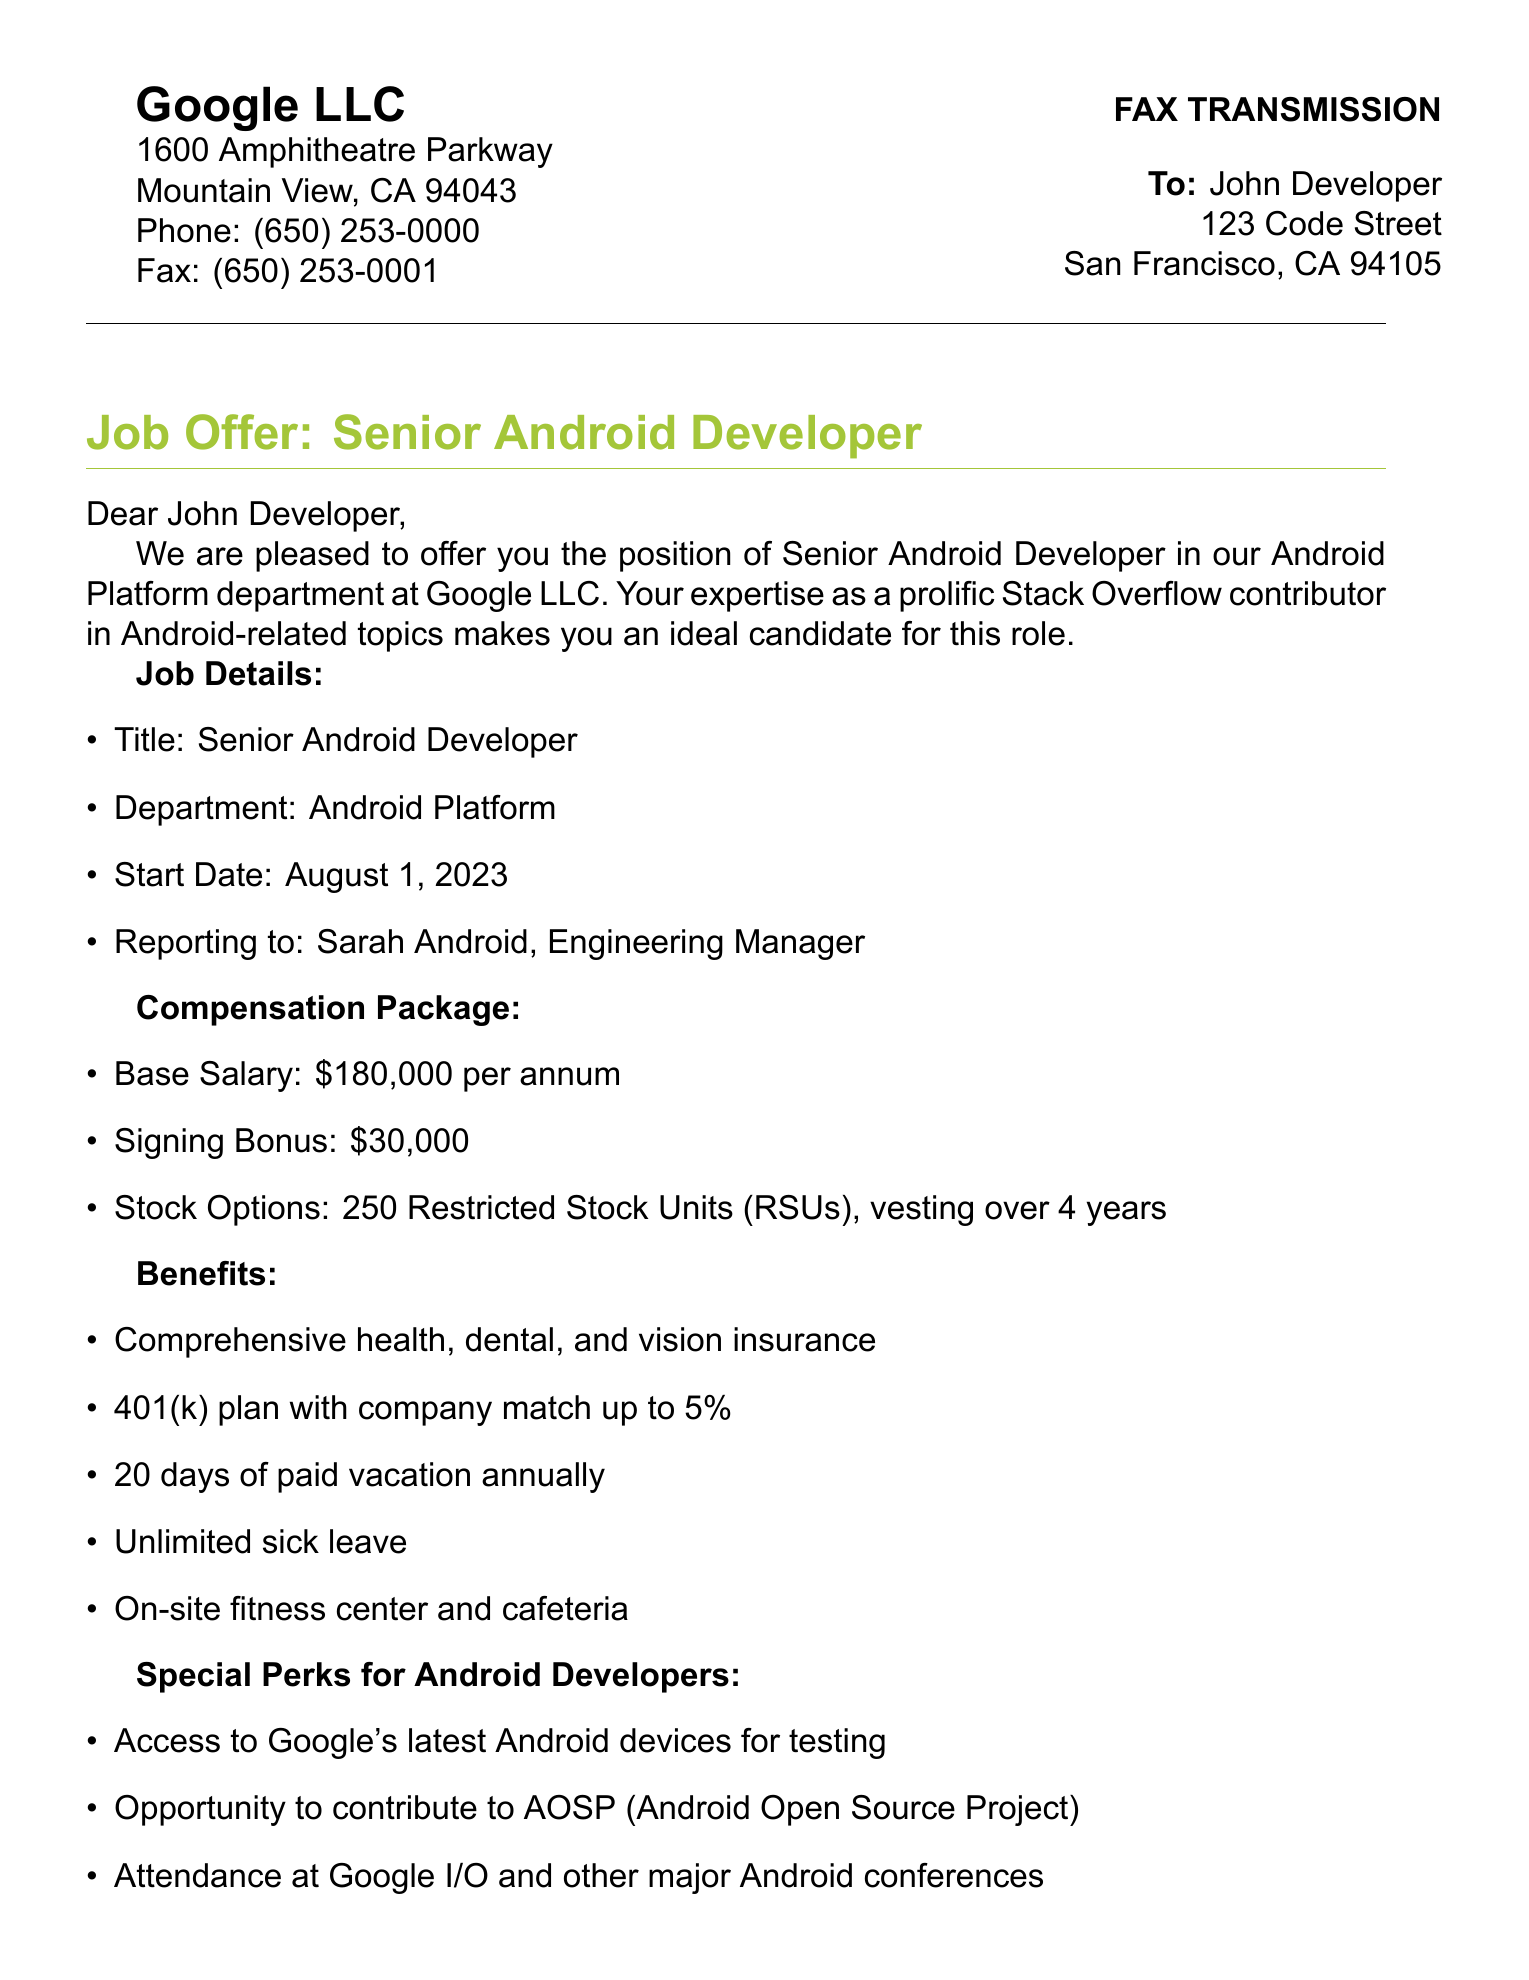What is the name of the company? The company is mentioned in the header of the document.
Answer: Google LLC What is the job title offered? The job title is stated in the section about the job offer.
Answer: Senior Android Developer What is the base salary for the position? The base salary is listed under the compensation package section.
Answer: $180,000 per annum How many Restricted Stock Units are offered? The number of stock options is provided in the compensation package.
Answer: 250 Who should the candidate report to? The reporting manager's name is mentioned in the job details section.
Answer: Sarah Android What is the start date for the position? The start date is included in the job details of the document.
Answer: August 1, 2023 How long is the signing bonus? The signing bonus is outlined in the compensation package and represents a one-time payment.
Answer: $30,000 What is the vacation time offered per year? The vacation time is detailed under the benefits section of the document.
Answer: 20 days What is one special perk for Android Developers? A specific perk for Android developers is provided in a dedicated section in the document.
Answer: Access to Google's latest Android devices for testing 